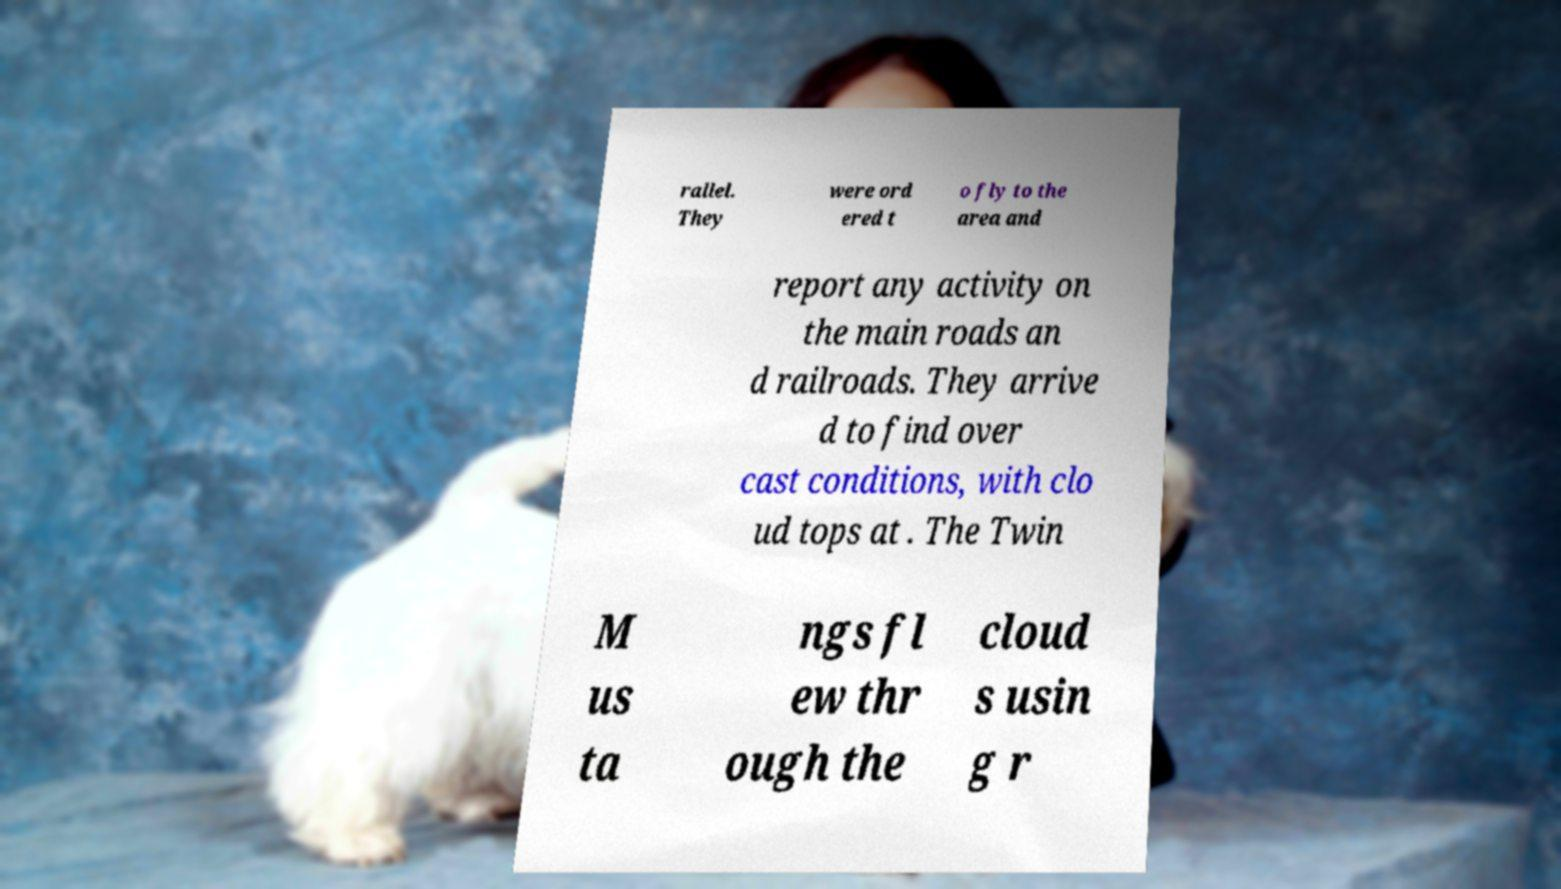There's text embedded in this image that I need extracted. Can you transcribe it verbatim? rallel. They were ord ered t o fly to the area and report any activity on the main roads an d railroads. They arrive d to find over cast conditions, with clo ud tops at . The Twin M us ta ngs fl ew thr ough the cloud s usin g r 